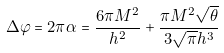Convert formula to latex. <formula><loc_0><loc_0><loc_500><loc_500>\Delta \varphi = 2 \pi \alpha = \frac { 6 \pi M ^ { 2 } } { h ^ { 2 } } + \frac { \pi M ^ { 2 } \sqrt { \theta } } { 3 \sqrt { \pi } h ^ { 3 } }</formula> 